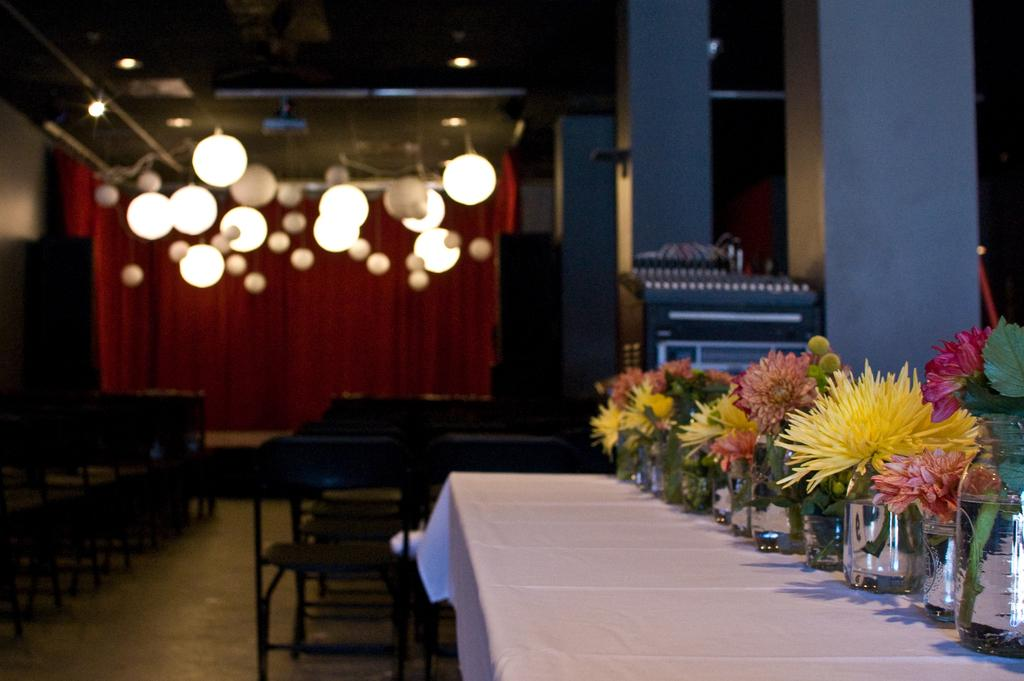What type of decorative lighting can be seen in the image? There are paper lanterns in the image. What type of window treatment is present in the image? There are curtains in the image. What type of furniture is visible in the image? There are chairs and tables in the image. What type of audio equipment is present in the image? There are speakers in the image. What type of architectural feature is present in the image? There are pillars in the image. What type of floral decorations are present in the image? There are flowers in the image. What type of material is present in the image? There is glass in the image. What type of greenery is present in the image? There are plants in the image. What type of table setting or display is present in the image? There is a table with items on it in the image. What type of skirt is visible in the image? There is no skirt present in the image. 